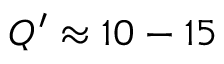Convert formula to latex. <formula><loc_0><loc_0><loc_500><loc_500>Q ^ { \prime } \approx 1 0 - 1 5</formula> 